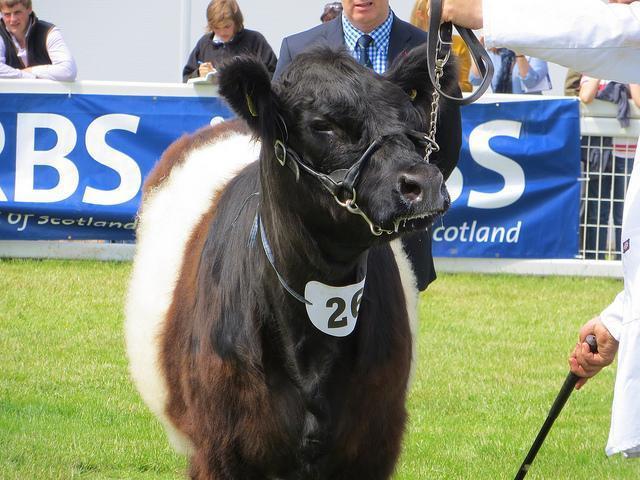How many cows are in the picture?
Give a very brief answer. 1. How many people are in the photo?
Give a very brief answer. 5. How many elephants are lying down?
Give a very brief answer. 0. 